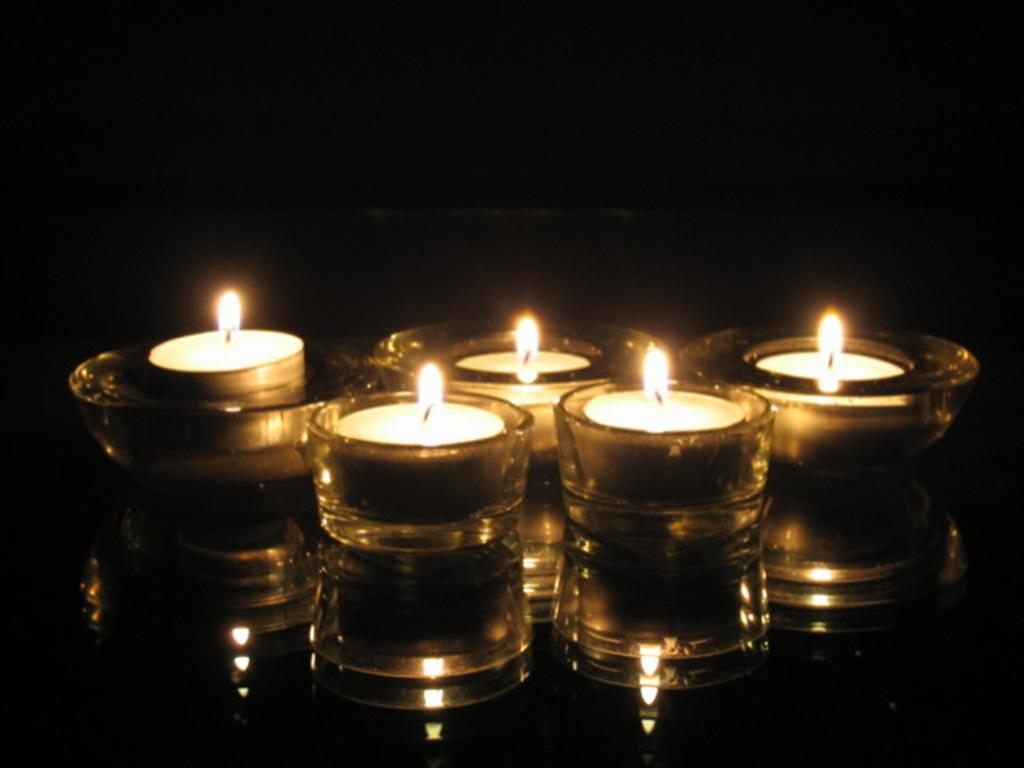How many tea light cups are visible in the image? There are five tea light cups in the image. What is inside each tea light cup? Each tea light cup has a candle in it. What color is the background of the image? The background of the image is black. Which actor is performing a magic trick with jelly in the image? There is no actor, magic trick, or jelly present in the image. 